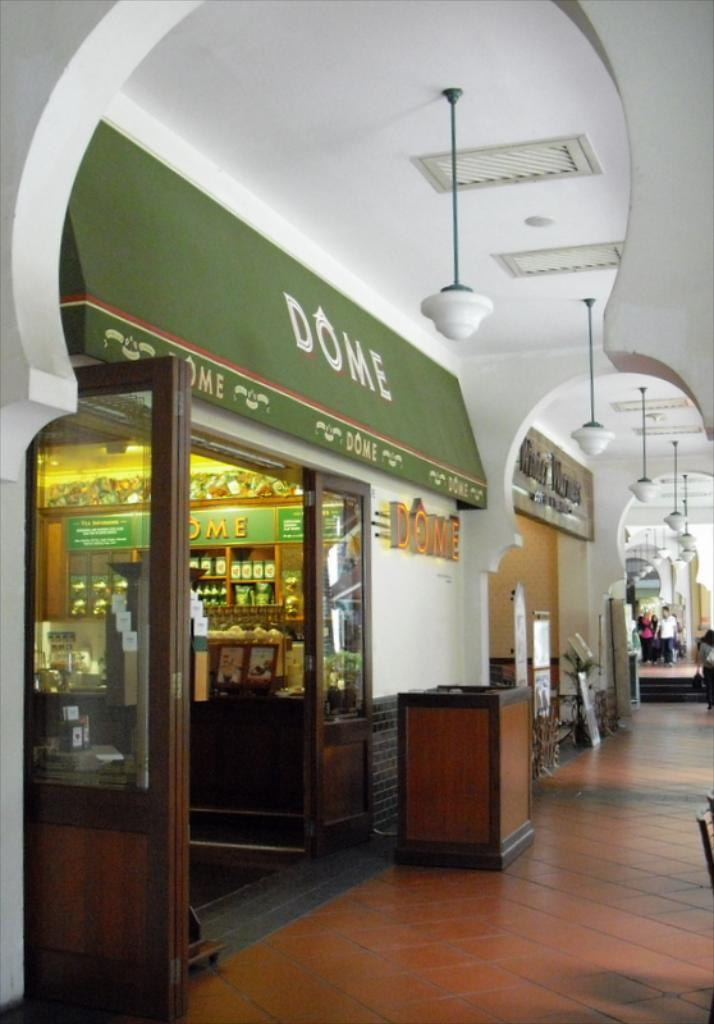Provide a one-sentence caption for the provided image. A photo of a store front of a store called Dome. 